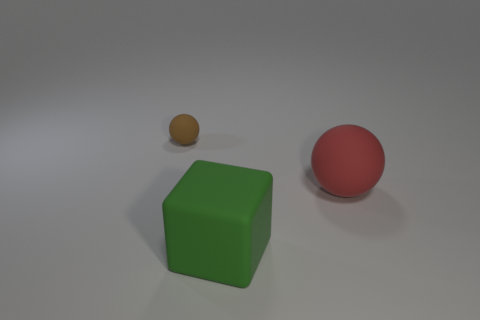What is the color of the other rubber thing that is the same size as the green rubber thing?
Your response must be concise. Red. Are there any tiny brown matte objects of the same shape as the big red rubber object?
Your answer should be compact. Yes. Is there a tiny sphere that is behind the rubber sphere that is to the right of the tiny brown sphere that is behind the large block?
Your answer should be very brief. Yes. What shape is the red matte thing that is the same size as the cube?
Your answer should be compact. Sphere. What is the color of the other large object that is the same shape as the brown rubber object?
Your answer should be compact. Red. How many things are green objects or large gray metallic objects?
Make the answer very short. 1. There is a matte thing behind the large red matte sphere; does it have the same shape as the large object in front of the large red matte ball?
Your response must be concise. No. What shape is the object that is on the right side of the large green rubber object?
Keep it short and to the point. Sphere. Is the number of tiny rubber spheres that are behind the small thing the same as the number of small rubber balls on the left side of the matte block?
Give a very brief answer. No. How many things are either tiny things or rubber balls that are to the right of the brown ball?
Your answer should be very brief. 2. 